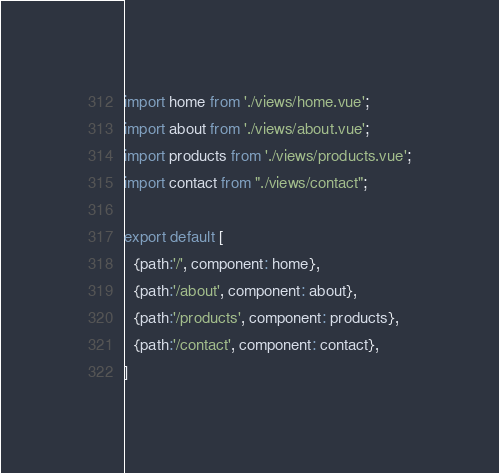<code> <loc_0><loc_0><loc_500><loc_500><_JavaScript_>import home from './views/home.vue';
import about from './views/about.vue';
import products from './views/products.vue';
import contact from "./views/contact";

export default [
  {path:'/', component: home},
  {path:'/about', component: about},
  {path:'/products', component: products},
  {path:'/contact', component: contact},
]
</code> 